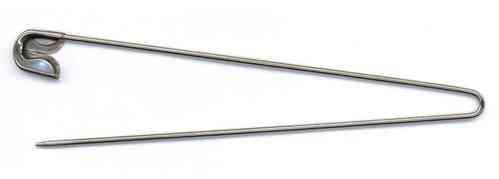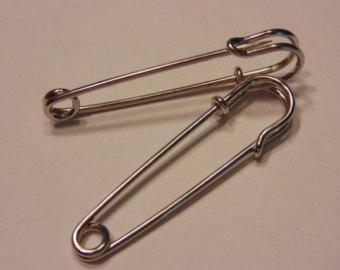The first image is the image on the left, the second image is the image on the right. Analyze the images presented: Is the assertion "The right image contains exactly two safety pins." valid? Answer yes or no. Yes. The first image is the image on the left, the second image is the image on the right. Examine the images to the left and right. Is the description "One image contains a single, open safety pin, and the other image shows two closed pins of a different style." accurate? Answer yes or no. Yes. 